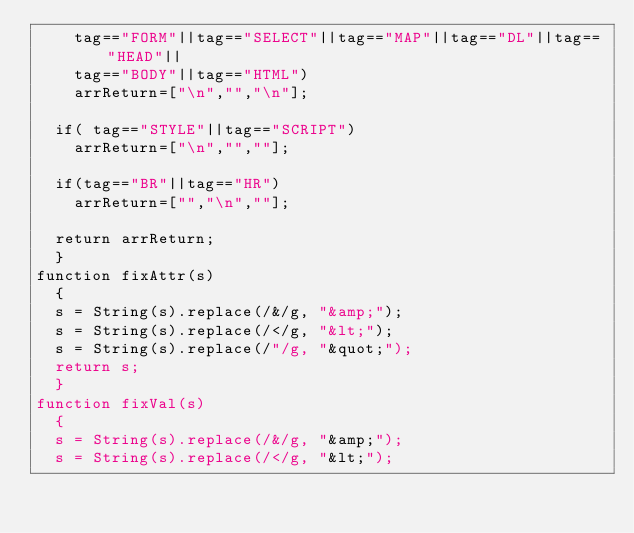<code> <loc_0><loc_0><loc_500><loc_500><_JavaScript_>		tag=="FORM"||tag=="SELECT"||tag=="MAP"||tag=="DL"||tag=="HEAD"||
		tag=="BODY"||tag=="HTML")
		arrReturn=["\n","","\n"];

	if(	tag=="STYLE"||tag=="SCRIPT")
		arrReturn=["\n","",""];

	if(tag=="BR"||tag=="HR")
		arrReturn=["","\n",""];

	return arrReturn;
	}
function fixAttr(s)
	{
	s = String(s).replace(/&/g, "&amp;");
	s = String(s).replace(/</g, "&lt;");
	s = String(s).replace(/"/g, "&quot;");
	return s;
	}
function fixVal(s)
	{
	s = String(s).replace(/&/g, "&amp;");
	s = String(s).replace(/</g, "&lt;");</code> 